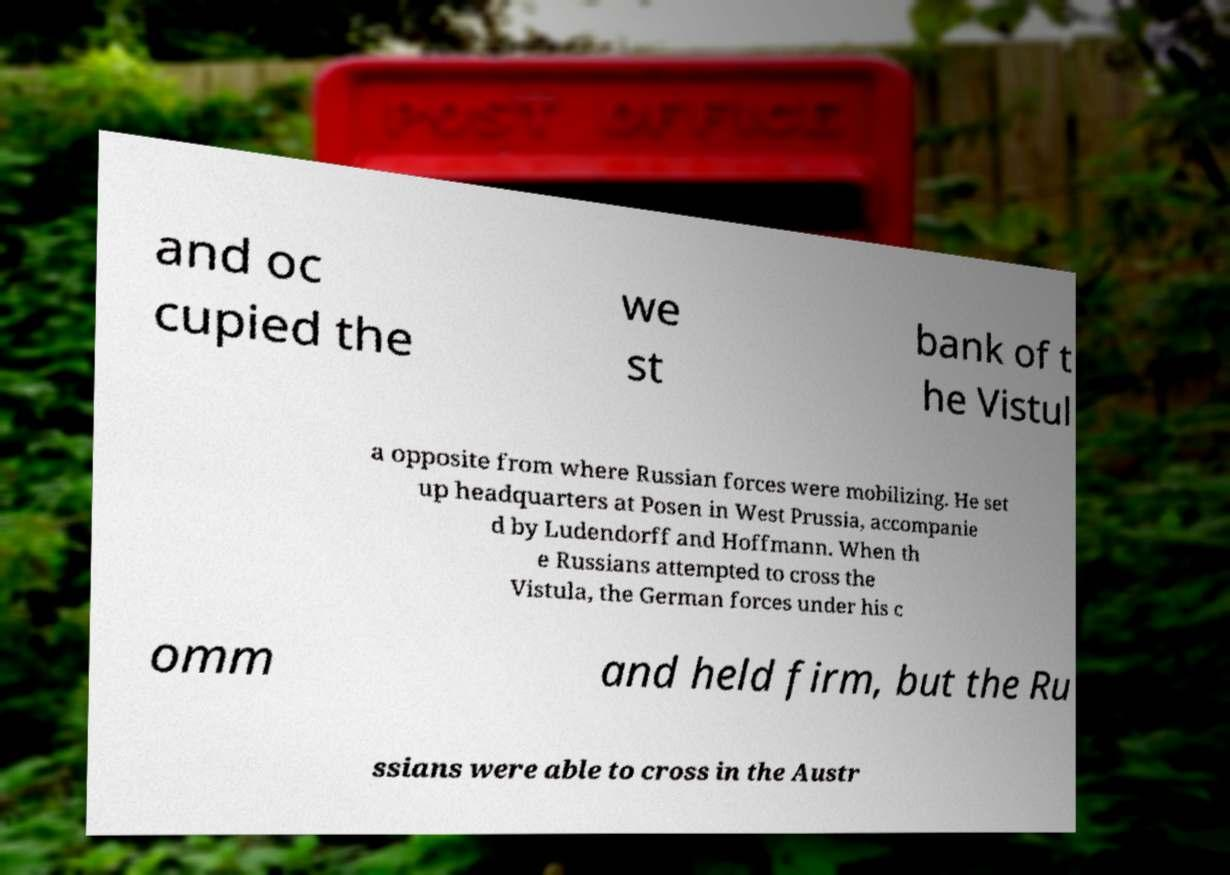Please read and relay the text visible in this image. What does it say? and oc cupied the we st bank of t he Vistul a opposite from where Russian forces were mobilizing. He set up headquarters at Posen in West Prussia, accompanie d by Ludendorff and Hoffmann. When th e Russians attempted to cross the Vistula, the German forces under his c omm and held firm, but the Ru ssians were able to cross in the Austr 